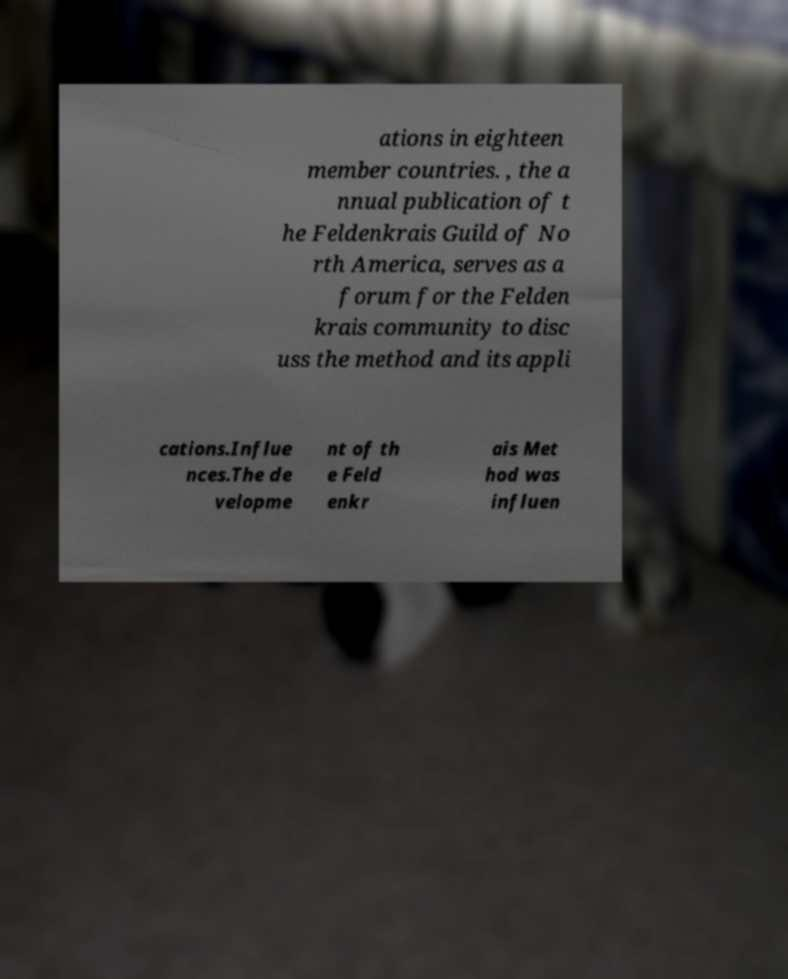For documentation purposes, I need the text within this image transcribed. Could you provide that? ations in eighteen member countries. , the a nnual publication of t he Feldenkrais Guild of No rth America, serves as a forum for the Felden krais community to disc uss the method and its appli cations.Influe nces.The de velopme nt of th e Feld enkr ais Met hod was influen 